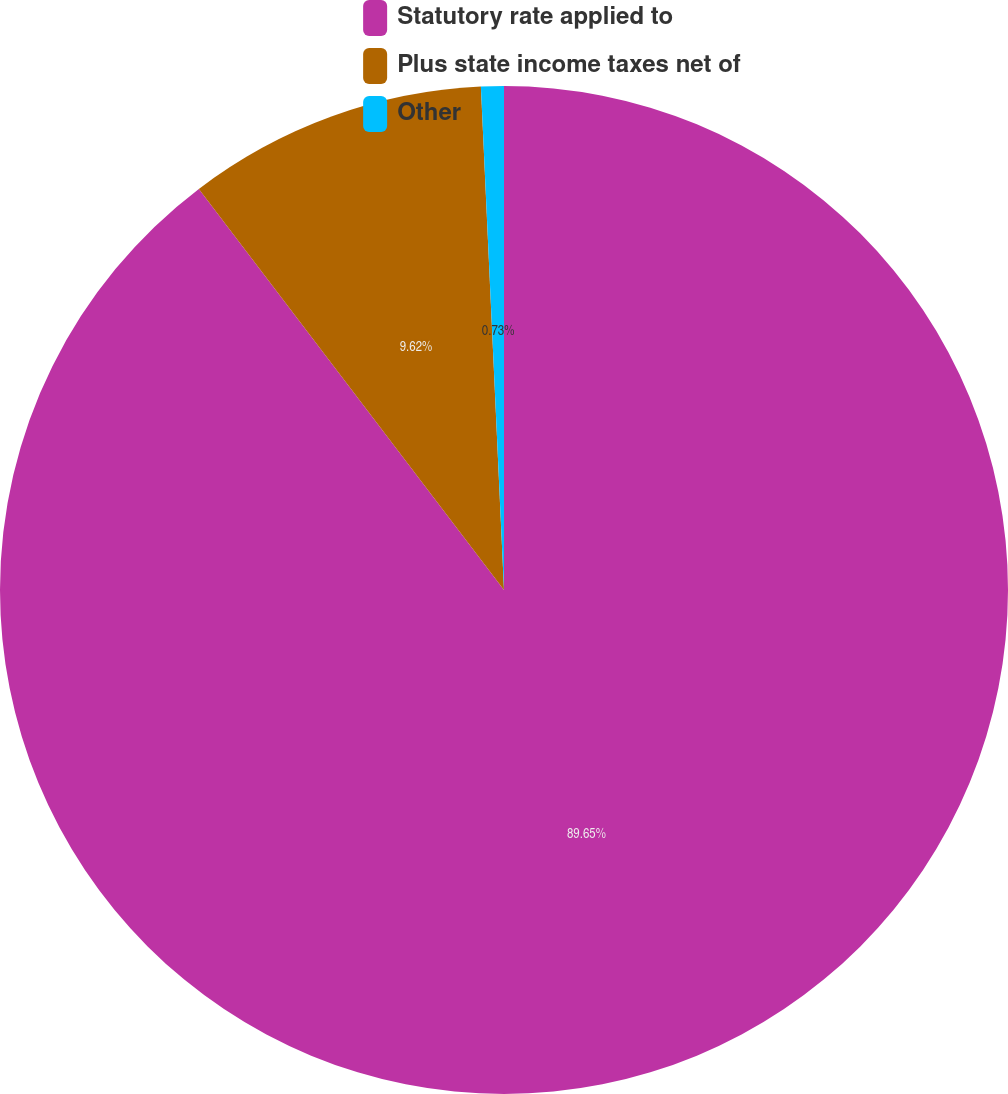<chart> <loc_0><loc_0><loc_500><loc_500><pie_chart><fcel>Statutory rate applied to<fcel>Plus state income taxes net of<fcel>Other<nl><fcel>89.64%<fcel>9.62%<fcel>0.73%<nl></chart> 